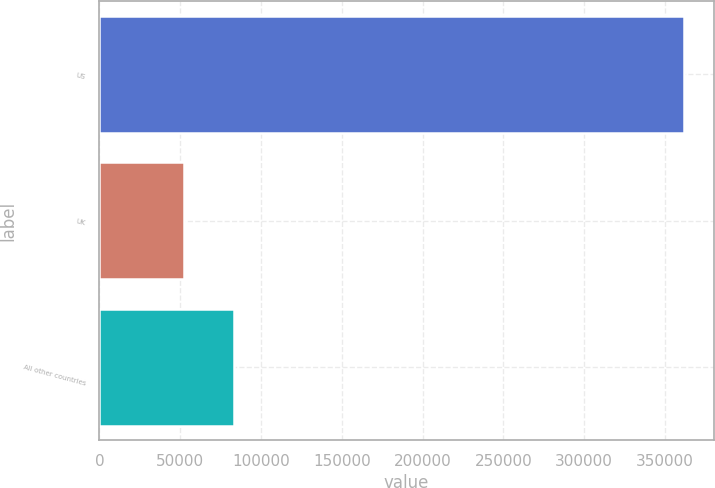<chart> <loc_0><loc_0><loc_500><loc_500><bar_chart><fcel>US<fcel>UK<fcel>All other countries<nl><fcel>361917<fcel>52539<fcel>83476.8<nl></chart> 